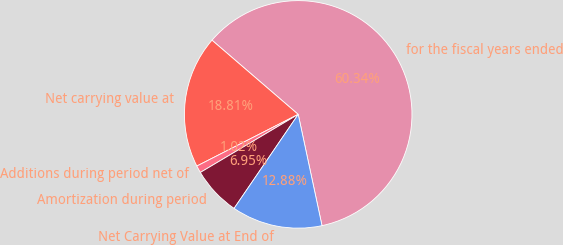<chart> <loc_0><loc_0><loc_500><loc_500><pie_chart><fcel>for the fiscal years ended<fcel>Net carrying value at<fcel>Additions during period net of<fcel>Amortization during period<fcel>Net Carrying Value at End of<nl><fcel>60.33%<fcel>18.81%<fcel>1.02%<fcel>6.95%<fcel>12.88%<nl></chart> 